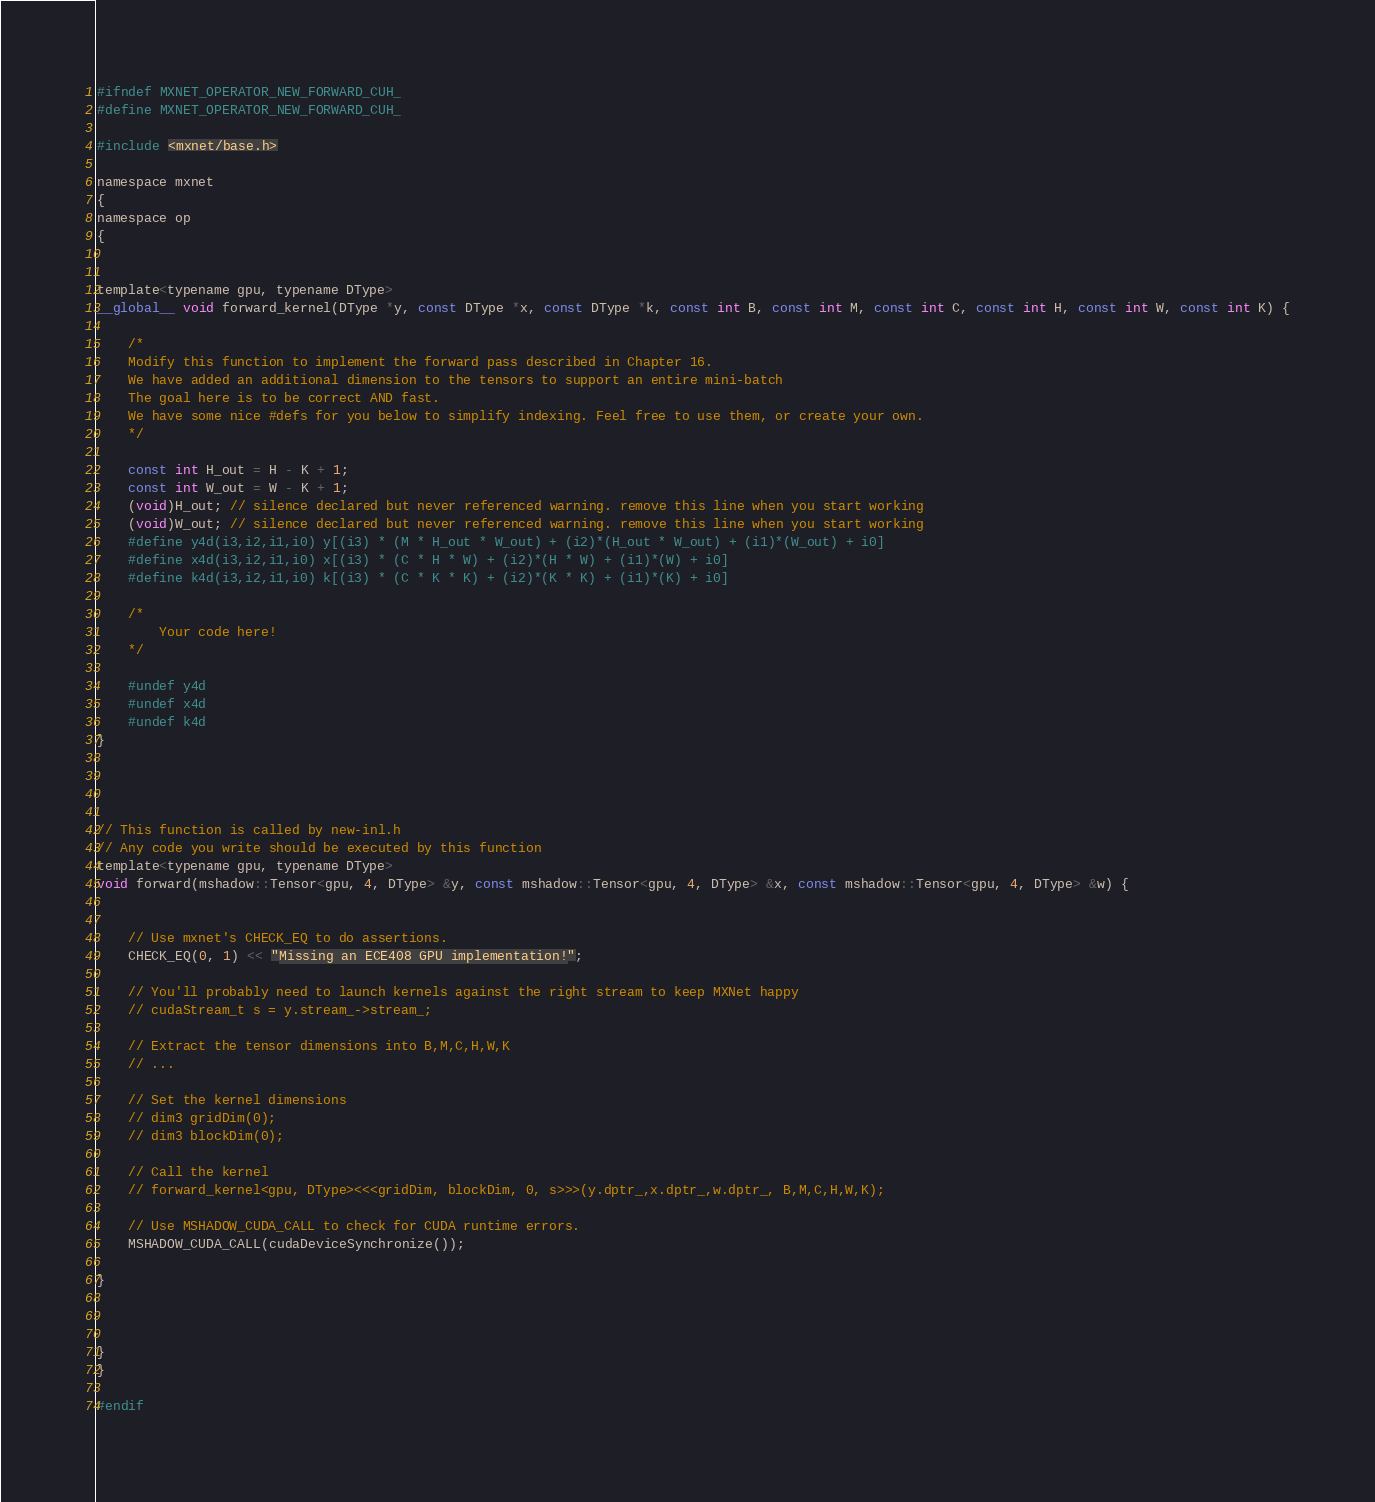Convert code to text. <code><loc_0><loc_0><loc_500><loc_500><_Cuda_>
#ifndef MXNET_OPERATOR_NEW_FORWARD_CUH_
#define MXNET_OPERATOR_NEW_FORWARD_CUH_

#include <mxnet/base.h>

namespace mxnet
{
namespace op
{


template<typename gpu, typename DType>
__global__ void forward_kernel(DType *y, const DType *x, const DType *k, const int B, const int M, const int C, const int H, const int W, const int K) {

    /*
    Modify this function to implement the forward pass described in Chapter 16.
    We have added an additional dimension to the tensors to support an entire mini-batch
    The goal here is to be correct AND fast.
    We have some nice #defs for you below to simplify indexing. Feel free to use them, or create your own.
    */

    const int H_out = H - K + 1;
    const int W_out = W - K + 1;
    (void)H_out; // silence declared but never referenced warning. remove this line when you start working
    (void)W_out; // silence declared but never referenced warning. remove this line when you start working
    #define y4d(i3,i2,i1,i0) y[(i3) * (M * H_out * W_out) + (i2)*(H_out * W_out) + (i1)*(W_out) + i0]
    #define x4d(i3,i2,i1,i0) x[(i3) * (C * H * W) + (i2)*(H * W) + (i1)*(W) + i0]
    #define k4d(i3,i2,i1,i0) k[(i3) * (C * K * K) + (i2)*(K * K) + (i1)*(K) + i0]

    /*
        Your code here!
    */

    #undef y4d
    #undef x4d
    #undef k4d
}




// This function is called by new-inl.h
// Any code you write should be executed by this function
template<typename gpu, typename DType>
void forward(mshadow::Tensor<gpu, 4, DType> &y, const mshadow::Tensor<gpu, 4, DType> &x, const mshadow::Tensor<gpu, 4, DType> &w) {
    

    // Use mxnet's CHECK_EQ to do assertions.
    CHECK_EQ(0, 1) << "Missing an ECE408 GPU implementation!";

    // You'll probably need to launch kernels against the right stream to keep MXNet happy
    // cudaStream_t s = y.stream_->stream_;

    // Extract the tensor dimensions into B,M,C,H,W,K
    // ...

    // Set the kernel dimensions
    // dim3 gridDim(0);
    // dim3 blockDim(0);

    // Call the kernel
    // forward_kernel<gpu, DType><<<gridDim, blockDim, 0, s>>>(y.dptr_,x.dptr_,w.dptr_, B,M,C,H,W,K);

    // Use MSHADOW_CUDA_CALL to check for CUDA runtime errors.
    MSHADOW_CUDA_CALL(cudaDeviceSynchronize());

}



}
}

#endif</code> 